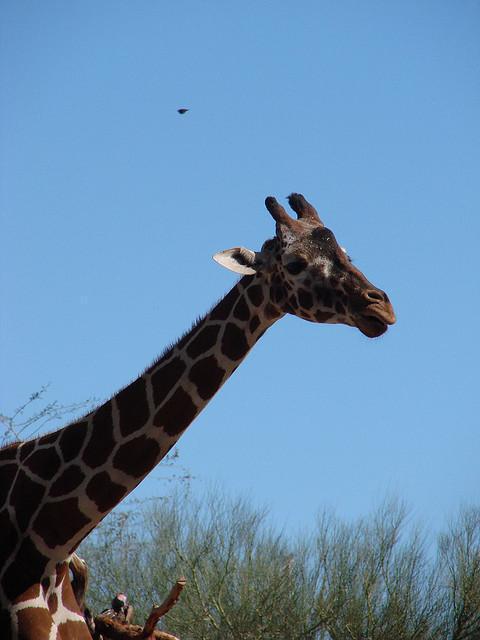How many giraffes can be seen?
Give a very brief answer. 1. How many sheep are standing?
Give a very brief answer. 0. 